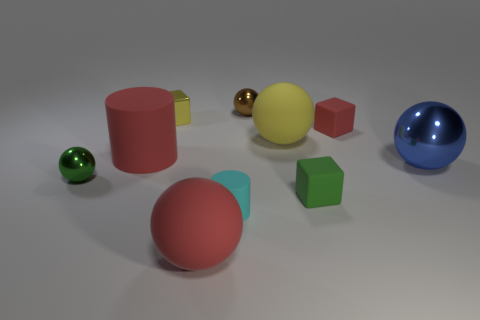Subtract all brown spheres. How many spheres are left? 4 Subtract all large red matte spheres. How many spheres are left? 4 Subtract all brown spheres. Subtract all purple cylinders. How many spheres are left? 4 Subtract all cylinders. How many objects are left? 8 Subtract all red cylinders. Subtract all blue things. How many objects are left? 8 Add 2 matte cylinders. How many matte cylinders are left? 4 Add 8 big red balls. How many big red balls exist? 9 Subtract 0 gray cylinders. How many objects are left? 10 